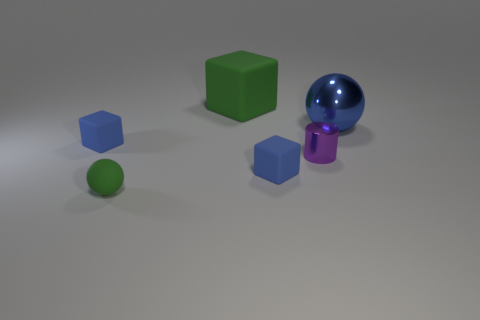Subtract all big cubes. How many cubes are left? 2 Subtract all blue blocks. How many blocks are left? 1 Add 3 red things. How many objects exist? 9 Add 2 blue blocks. How many blue blocks exist? 4 Subtract 1 blue cubes. How many objects are left? 5 Subtract all cylinders. How many objects are left? 5 Subtract 1 cylinders. How many cylinders are left? 0 Subtract all yellow cylinders. Subtract all blue spheres. How many cylinders are left? 1 Subtract all yellow cylinders. How many green cubes are left? 1 Subtract all green blocks. Subtract all brown cubes. How many objects are left? 5 